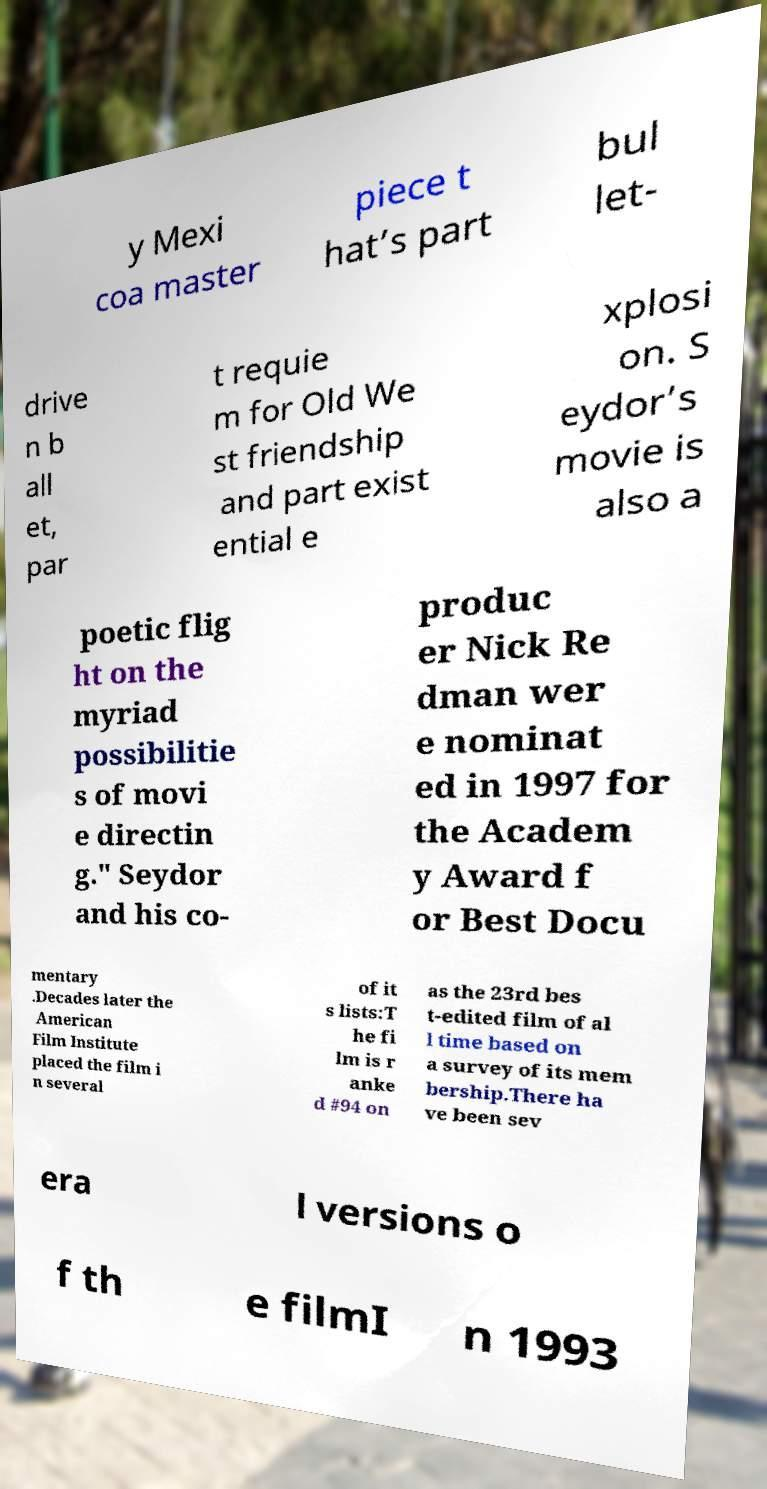Can you read and provide the text displayed in the image?This photo seems to have some interesting text. Can you extract and type it out for me? y Mexi coa master piece t hat’s part bul let- drive n b all et, par t requie m for Old We st friendship and part exist ential e xplosi on. S eydor’s movie is also a poetic flig ht on the myriad possibilitie s of movi e directin g." Seydor and his co- produc er Nick Re dman wer e nominat ed in 1997 for the Academ y Award f or Best Docu mentary .Decades later the American Film Institute placed the film i n several of it s lists:T he fi lm is r anke d #94 on as the 23rd bes t-edited film of al l time based on a survey of its mem bership.There ha ve been sev era l versions o f th e filmI n 1993 